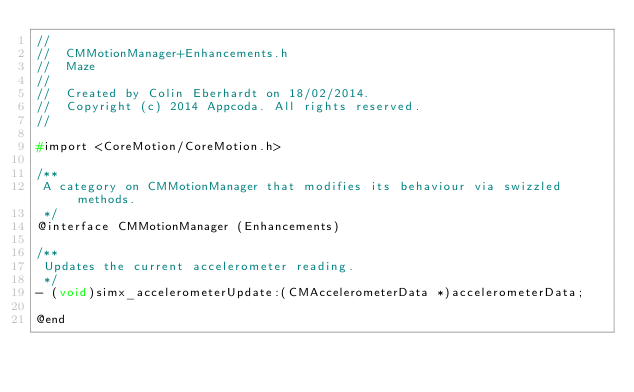Convert code to text. <code><loc_0><loc_0><loc_500><loc_500><_C_>//
//  CMMotionManager+Enhancements.h
//  Maze
//
//  Created by Colin Eberhardt on 18/02/2014.
//  Copyright (c) 2014 Appcoda. All rights reserved.
//

#import <CoreMotion/CoreMotion.h>

/**
 A category on CMMotionManager that modifies its behaviour via swizzled methods.
 */
@interface CMMotionManager (Enhancements)

/**
 Updates the current accelerometer reading.
 */
- (void)simx_accelerometerUpdate:(CMAccelerometerData *)accelerometerData;

@end
</code> 